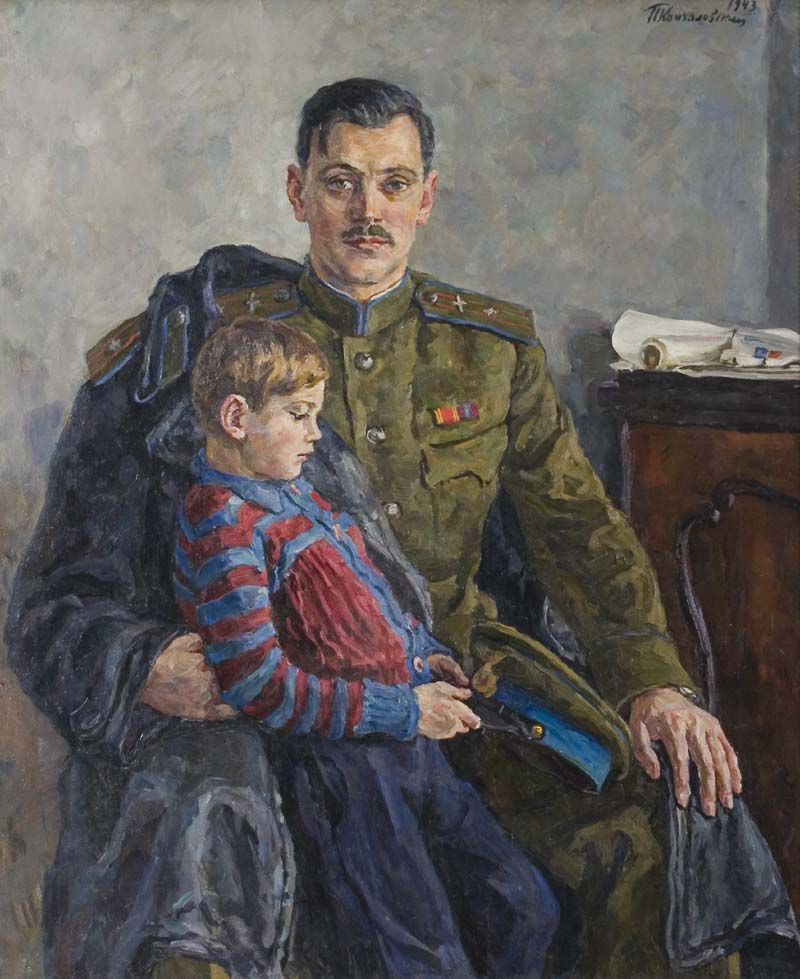Can you tell me more about the expression on the man's face and its artistic rendering? The man's expression is stoic yet tender, reflecting a strong sense of responsibility combined with paternal affection. Artistically, the artist has skillfully used a restrained color palette and subtle brushstrokes around the eyes and mouth to convey these complex emotions. The slightly furrowed brow and the direct gaze out of the canvas engage the viewer, making it a compelling portrait of military and familial duty. 